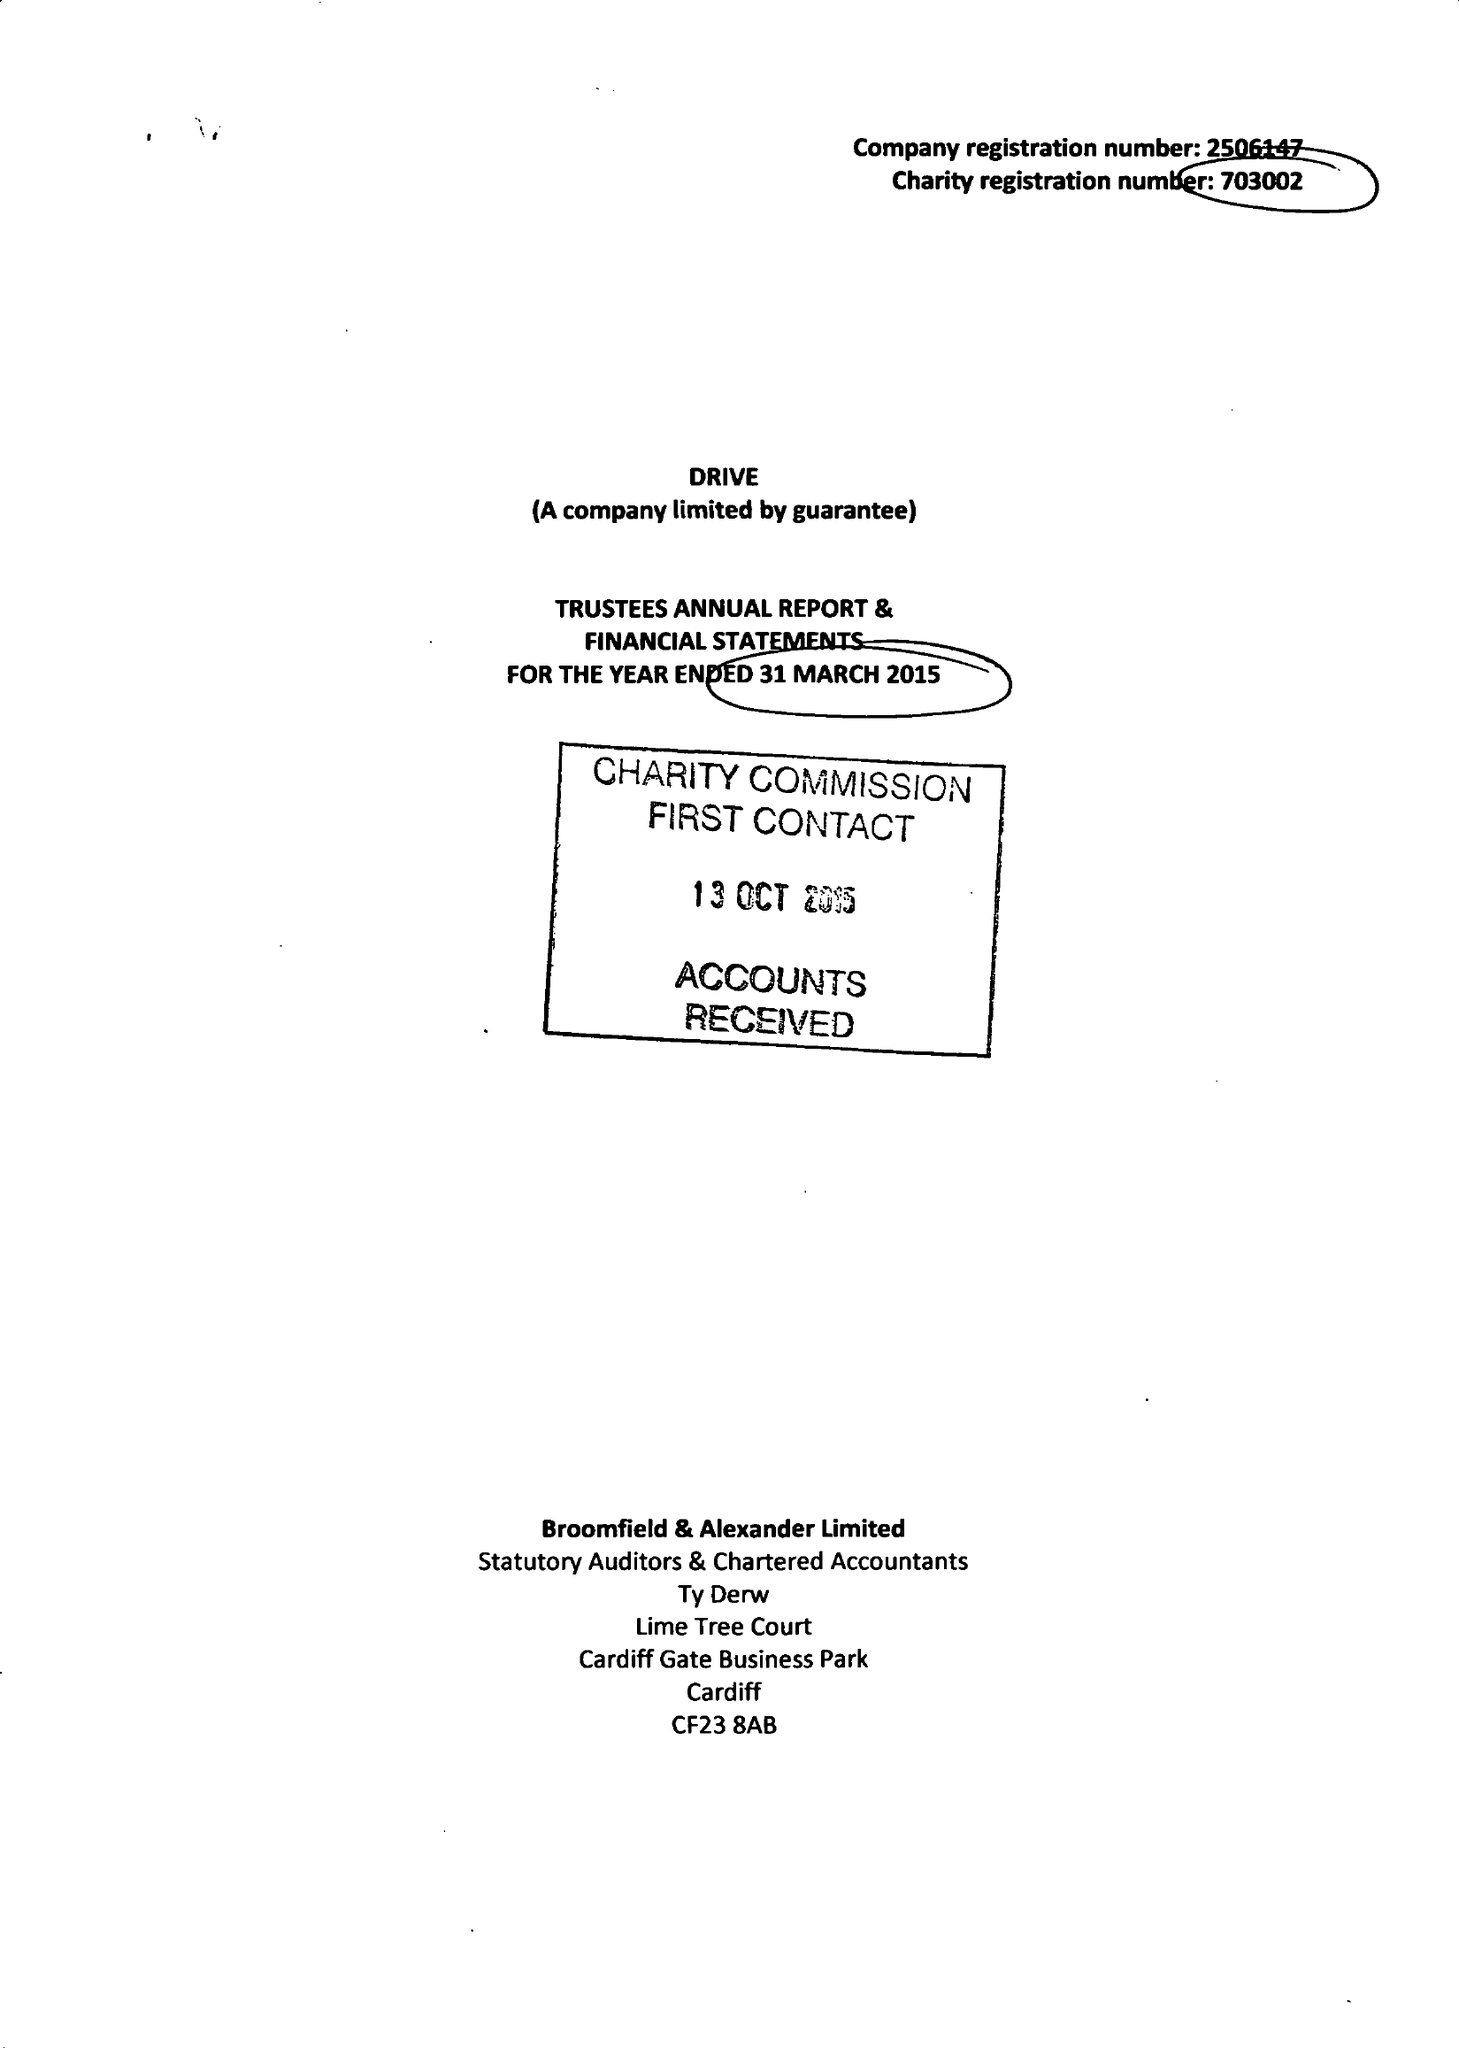What is the value for the address__post_town?
Answer the question using a single word or phrase. CARDIFF 